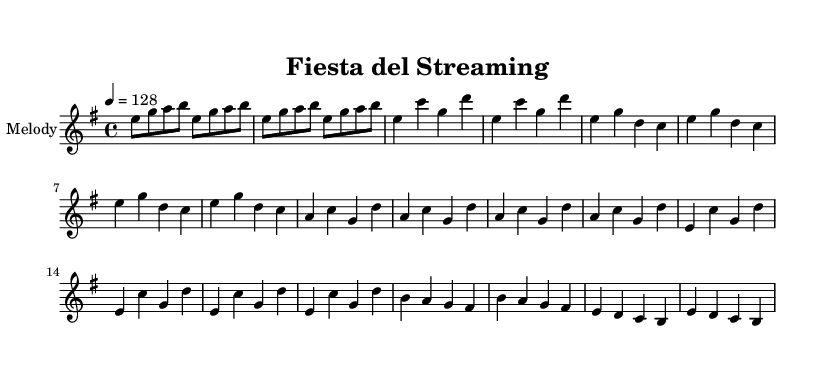What is the key signature of this music? The key signature shown in the music indicates E minor, which has one sharp (F#). This is determined by looking at the key signature at the beginning of the score.
Answer: E minor What is the time signature of this music? The time signature present in the music is 4/4, which can be identified at the beginning of the score. This means there are four beats in each measure.
Answer: 4/4 What is the tempo marking of this piece? The tempo marking indicates a speed of 128 beats per minute (bpm). It's specified in the tempo line at the beginning, highlighting the pace of the piece.
Answer: 128 How many bars are in the verse section? The verse section consists of 4 bars, which can be counted directly from the music notation in the verse area of the score.
Answer: 4 What is the main rhythm pattern in the chorus? The main rhythm pattern in the chorus is based on quarter notes, as seen in the repetitive nature of the chorus notations, emphasizing a steady, driving rhythm.
Answer: Quarter notes What lyrical theme is approached in the pre-chorus? The pre-chorus conveys an energetic and lively vibe, centering around themes of celebration and enjoyment associated with streaming and fun; this can be derived from the lyrics presented above.
Answer: Celebration and enjoyment How does the bridge compare rhythmically to the verse? The bridge introduces a slight variation in rhythm compared to the verse, featuring a slower descending pattern that creates a contrast, as observed with the distinct notes and phrasing from the verse.
Answer: Variation in rhythm 